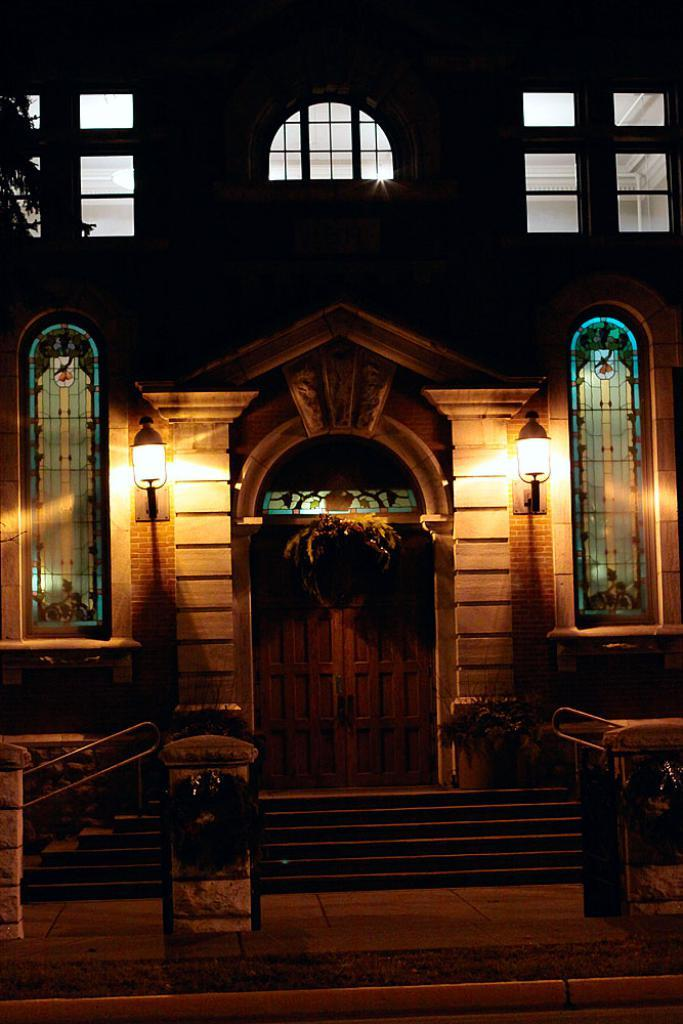Where was the picture taken? The picture was clicked outside. What is the main subject in the center of the image? There is a building in the center of the image. What architectural feature can be seen in the image? There are stairs in the image. What part of the natural environment is visible in the image? The ground is visible in the image. What type of lighting is present in the image? Wall lamps are present in the image. What can be used for entering or exiting the building? There is a door in the image. What allows natural light to enter the building? Windows are visible in the image. What type of fruit is being used as a decoration in the bedroom in the image? There is no bedroom or fruit present in the image; it is an outdoor scene featuring a building, stairs, the ground, wall lamps, a door, and windows. 